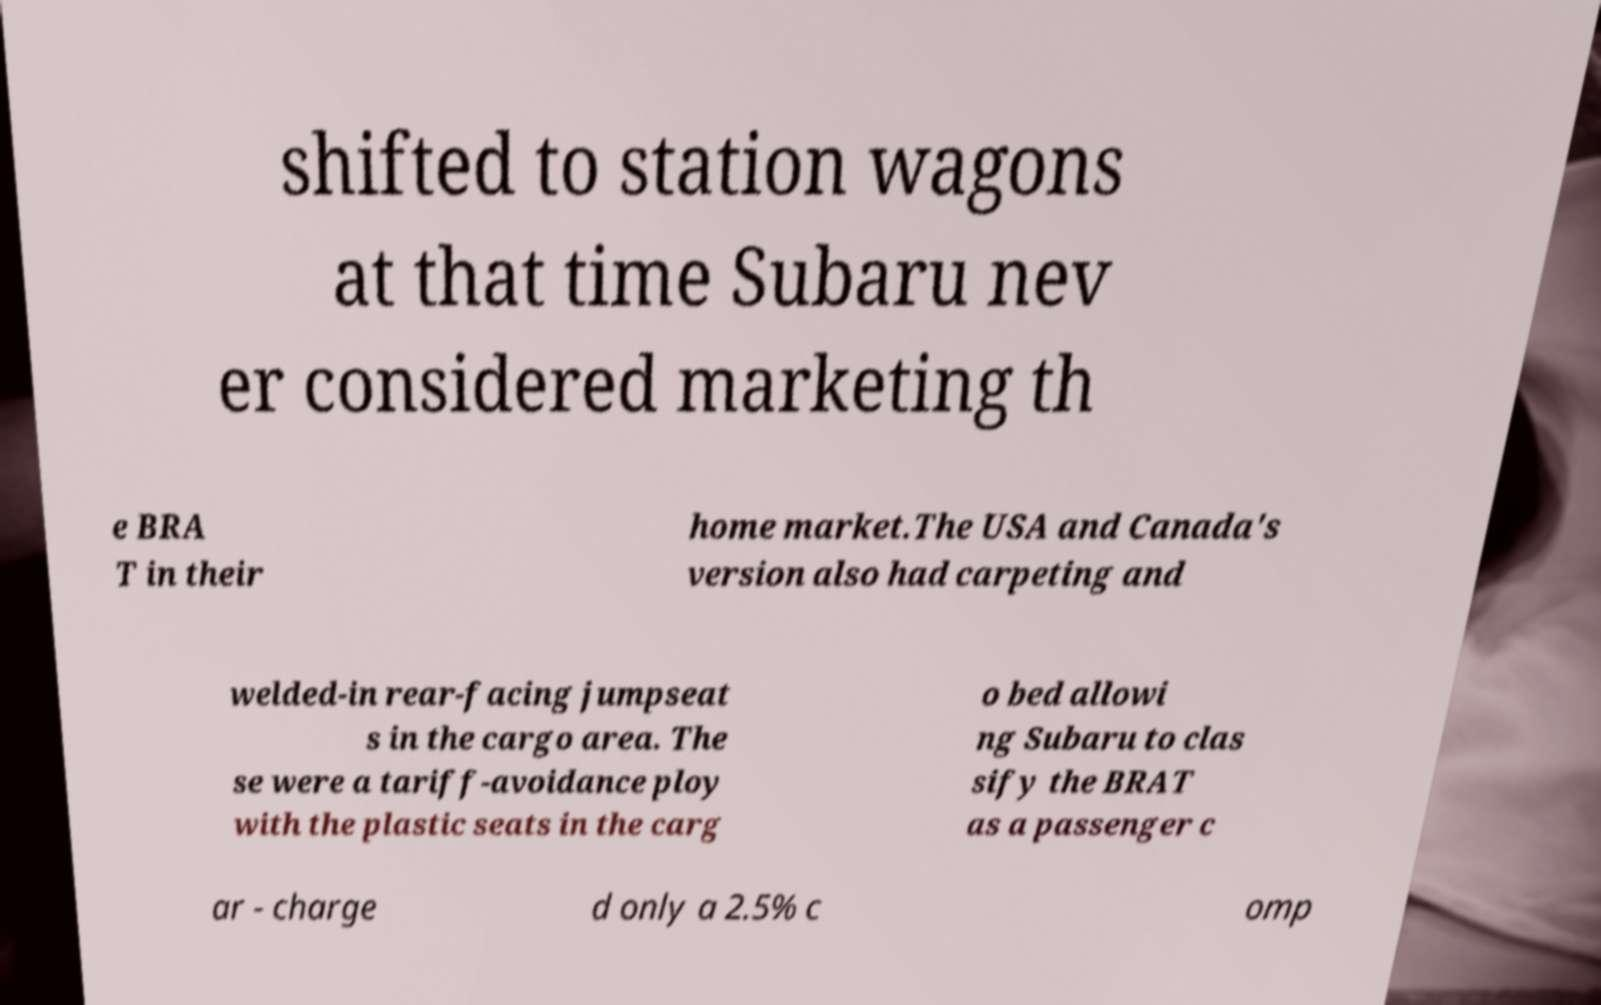Could you extract and type out the text from this image? shifted to station wagons at that time Subaru nev er considered marketing th e BRA T in their home market.The USA and Canada's version also had carpeting and welded-in rear-facing jumpseat s in the cargo area. The se were a tariff-avoidance ploy with the plastic seats in the carg o bed allowi ng Subaru to clas sify the BRAT as a passenger c ar - charge d only a 2.5% c omp 